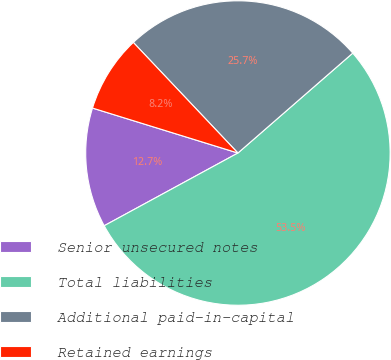<chart> <loc_0><loc_0><loc_500><loc_500><pie_chart><fcel>Senior unsecured notes<fcel>Total liabilities<fcel>Additional paid-in-capital<fcel>Retained earnings<nl><fcel>12.7%<fcel>53.47%<fcel>25.66%<fcel>8.17%<nl></chart> 